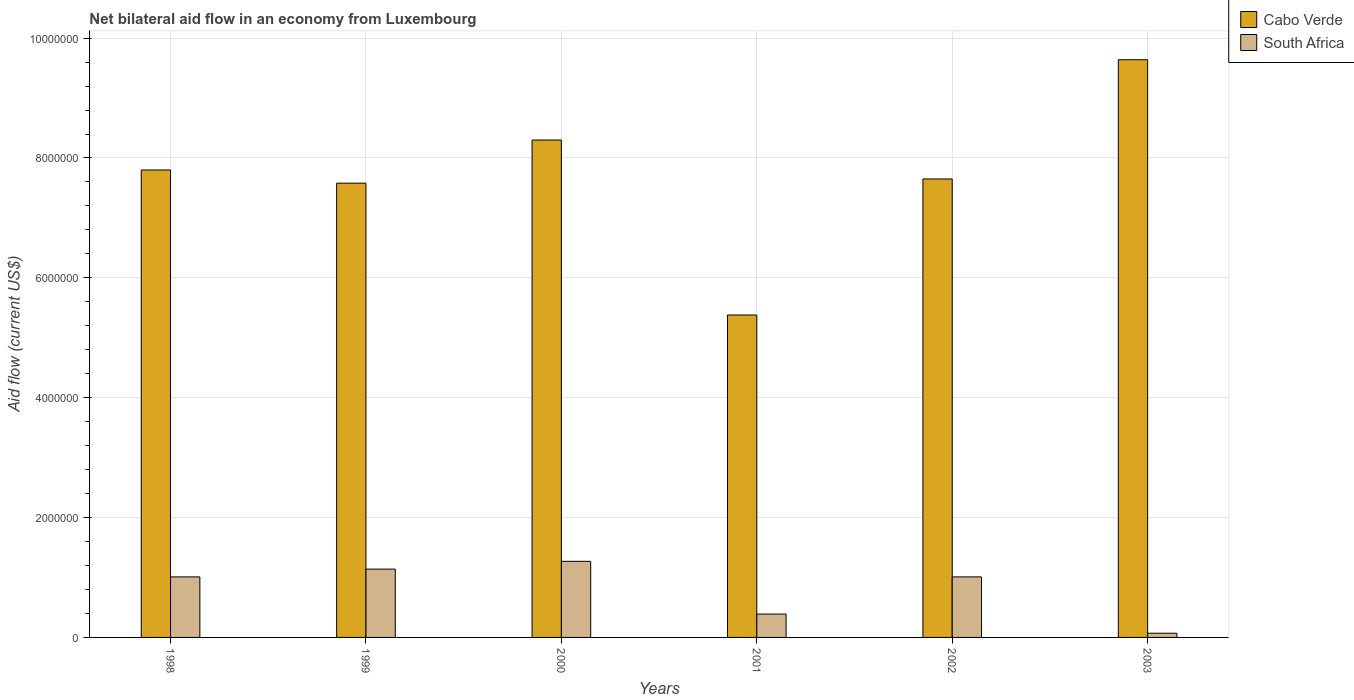How many different coloured bars are there?
Ensure brevity in your answer.  2. Are the number of bars per tick equal to the number of legend labels?
Offer a terse response. Yes. Are the number of bars on each tick of the X-axis equal?
Keep it short and to the point. Yes. How many bars are there on the 5th tick from the right?
Your response must be concise. 2. In how many cases, is the number of bars for a given year not equal to the number of legend labels?
Provide a succinct answer. 0. What is the net bilateral aid flow in Cabo Verde in 1999?
Provide a succinct answer. 7.58e+06. Across all years, what is the maximum net bilateral aid flow in Cabo Verde?
Ensure brevity in your answer.  9.64e+06. Across all years, what is the minimum net bilateral aid flow in South Africa?
Keep it short and to the point. 7.00e+04. In which year was the net bilateral aid flow in South Africa maximum?
Offer a terse response. 2000. In which year was the net bilateral aid flow in Cabo Verde minimum?
Give a very brief answer. 2001. What is the total net bilateral aid flow in Cabo Verde in the graph?
Make the answer very short. 4.64e+07. What is the difference between the net bilateral aid flow in South Africa in 2000 and that in 2001?
Your response must be concise. 8.80e+05. What is the difference between the net bilateral aid flow in Cabo Verde in 2000 and the net bilateral aid flow in South Africa in 1998?
Make the answer very short. 7.29e+06. What is the average net bilateral aid flow in Cabo Verde per year?
Give a very brief answer. 7.72e+06. In the year 1999, what is the difference between the net bilateral aid flow in South Africa and net bilateral aid flow in Cabo Verde?
Offer a terse response. -6.44e+06. In how many years, is the net bilateral aid flow in Cabo Verde greater than 7200000 US$?
Offer a terse response. 5. What is the ratio of the net bilateral aid flow in Cabo Verde in 2001 to that in 2003?
Ensure brevity in your answer.  0.56. Is the difference between the net bilateral aid flow in South Africa in 1998 and 2000 greater than the difference between the net bilateral aid flow in Cabo Verde in 1998 and 2000?
Your response must be concise. Yes. What is the difference between the highest and the second highest net bilateral aid flow in Cabo Verde?
Give a very brief answer. 1.34e+06. What is the difference between the highest and the lowest net bilateral aid flow in South Africa?
Keep it short and to the point. 1.20e+06. In how many years, is the net bilateral aid flow in South Africa greater than the average net bilateral aid flow in South Africa taken over all years?
Provide a short and direct response. 4. Is the sum of the net bilateral aid flow in Cabo Verde in 1998 and 1999 greater than the maximum net bilateral aid flow in South Africa across all years?
Offer a very short reply. Yes. What does the 1st bar from the left in 1999 represents?
Provide a short and direct response. Cabo Verde. What does the 2nd bar from the right in 1998 represents?
Your response must be concise. Cabo Verde. How many bars are there?
Your response must be concise. 12. Are all the bars in the graph horizontal?
Provide a succinct answer. No. How many years are there in the graph?
Give a very brief answer. 6. What is the difference between two consecutive major ticks on the Y-axis?
Keep it short and to the point. 2.00e+06. Does the graph contain any zero values?
Offer a very short reply. No. Does the graph contain grids?
Offer a terse response. Yes. Where does the legend appear in the graph?
Your answer should be very brief. Top right. How many legend labels are there?
Give a very brief answer. 2. How are the legend labels stacked?
Provide a short and direct response. Vertical. What is the title of the graph?
Offer a very short reply. Net bilateral aid flow in an economy from Luxembourg. What is the Aid flow (current US$) of Cabo Verde in 1998?
Your answer should be compact. 7.80e+06. What is the Aid flow (current US$) of South Africa in 1998?
Your answer should be very brief. 1.01e+06. What is the Aid flow (current US$) in Cabo Verde in 1999?
Your answer should be compact. 7.58e+06. What is the Aid flow (current US$) in South Africa in 1999?
Ensure brevity in your answer.  1.14e+06. What is the Aid flow (current US$) in Cabo Verde in 2000?
Keep it short and to the point. 8.30e+06. What is the Aid flow (current US$) of South Africa in 2000?
Make the answer very short. 1.27e+06. What is the Aid flow (current US$) of Cabo Verde in 2001?
Give a very brief answer. 5.38e+06. What is the Aid flow (current US$) in South Africa in 2001?
Ensure brevity in your answer.  3.90e+05. What is the Aid flow (current US$) of Cabo Verde in 2002?
Keep it short and to the point. 7.65e+06. What is the Aid flow (current US$) in South Africa in 2002?
Make the answer very short. 1.01e+06. What is the Aid flow (current US$) of Cabo Verde in 2003?
Make the answer very short. 9.64e+06. Across all years, what is the maximum Aid flow (current US$) in Cabo Verde?
Offer a very short reply. 9.64e+06. Across all years, what is the maximum Aid flow (current US$) of South Africa?
Your answer should be compact. 1.27e+06. Across all years, what is the minimum Aid flow (current US$) of Cabo Verde?
Your answer should be compact. 5.38e+06. Across all years, what is the minimum Aid flow (current US$) in South Africa?
Make the answer very short. 7.00e+04. What is the total Aid flow (current US$) in Cabo Verde in the graph?
Your answer should be very brief. 4.64e+07. What is the total Aid flow (current US$) in South Africa in the graph?
Make the answer very short. 4.89e+06. What is the difference between the Aid flow (current US$) of South Africa in 1998 and that in 1999?
Offer a terse response. -1.30e+05. What is the difference between the Aid flow (current US$) in Cabo Verde in 1998 and that in 2000?
Offer a terse response. -5.00e+05. What is the difference between the Aid flow (current US$) of South Africa in 1998 and that in 2000?
Your response must be concise. -2.60e+05. What is the difference between the Aid flow (current US$) of Cabo Verde in 1998 and that in 2001?
Make the answer very short. 2.42e+06. What is the difference between the Aid flow (current US$) of South Africa in 1998 and that in 2001?
Offer a terse response. 6.20e+05. What is the difference between the Aid flow (current US$) in Cabo Verde in 1998 and that in 2002?
Ensure brevity in your answer.  1.50e+05. What is the difference between the Aid flow (current US$) of Cabo Verde in 1998 and that in 2003?
Your answer should be very brief. -1.84e+06. What is the difference between the Aid flow (current US$) in South Africa in 1998 and that in 2003?
Your answer should be compact. 9.40e+05. What is the difference between the Aid flow (current US$) in Cabo Verde in 1999 and that in 2000?
Provide a succinct answer. -7.20e+05. What is the difference between the Aid flow (current US$) in Cabo Verde in 1999 and that in 2001?
Your answer should be compact. 2.20e+06. What is the difference between the Aid flow (current US$) in South Africa in 1999 and that in 2001?
Your response must be concise. 7.50e+05. What is the difference between the Aid flow (current US$) of Cabo Verde in 1999 and that in 2003?
Offer a very short reply. -2.06e+06. What is the difference between the Aid flow (current US$) of South Africa in 1999 and that in 2003?
Ensure brevity in your answer.  1.07e+06. What is the difference between the Aid flow (current US$) of Cabo Verde in 2000 and that in 2001?
Offer a terse response. 2.92e+06. What is the difference between the Aid flow (current US$) in South Africa in 2000 and that in 2001?
Your answer should be very brief. 8.80e+05. What is the difference between the Aid flow (current US$) in Cabo Verde in 2000 and that in 2002?
Provide a succinct answer. 6.50e+05. What is the difference between the Aid flow (current US$) in Cabo Verde in 2000 and that in 2003?
Your answer should be compact. -1.34e+06. What is the difference between the Aid flow (current US$) of South Africa in 2000 and that in 2003?
Make the answer very short. 1.20e+06. What is the difference between the Aid flow (current US$) of Cabo Verde in 2001 and that in 2002?
Provide a short and direct response. -2.27e+06. What is the difference between the Aid flow (current US$) in South Africa in 2001 and that in 2002?
Your answer should be compact. -6.20e+05. What is the difference between the Aid flow (current US$) of Cabo Verde in 2001 and that in 2003?
Your answer should be compact. -4.26e+06. What is the difference between the Aid flow (current US$) of Cabo Verde in 2002 and that in 2003?
Ensure brevity in your answer.  -1.99e+06. What is the difference between the Aid flow (current US$) in South Africa in 2002 and that in 2003?
Your response must be concise. 9.40e+05. What is the difference between the Aid flow (current US$) of Cabo Verde in 1998 and the Aid flow (current US$) of South Africa in 1999?
Provide a short and direct response. 6.66e+06. What is the difference between the Aid flow (current US$) in Cabo Verde in 1998 and the Aid flow (current US$) in South Africa in 2000?
Ensure brevity in your answer.  6.53e+06. What is the difference between the Aid flow (current US$) in Cabo Verde in 1998 and the Aid flow (current US$) in South Africa in 2001?
Make the answer very short. 7.41e+06. What is the difference between the Aid flow (current US$) in Cabo Verde in 1998 and the Aid flow (current US$) in South Africa in 2002?
Your answer should be very brief. 6.79e+06. What is the difference between the Aid flow (current US$) in Cabo Verde in 1998 and the Aid flow (current US$) in South Africa in 2003?
Keep it short and to the point. 7.73e+06. What is the difference between the Aid flow (current US$) of Cabo Verde in 1999 and the Aid flow (current US$) of South Africa in 2000?
Provide a succinct answer. 6.31e+06. What is the difference between the Aid flow (current US$) in Cabo Verde in 1999 and the Aid flow (current US$) in South Africa in 2001?
Offer a terse response. 7.19e+06. What is the difference between the Aid flow (current US$) of Cabo Verde in 1999 and the Aid flow (current US$) of South Africa in 2002?
Your answer should be compact. 6.57e+06. What is the difference between the Aid flow (current US$) of Cabo Verde in 1999 and the Aid flow (current US$) of South Africa in 2003?
Your answer should be compact. 7.51e+06. What is the difference between the Aid flow (current US$) in Cabo Verde in 2000 and the Aid flow (current US$) in South Africa in 2001?
Ensure brevity in your answer.  7.91e+06. What is the difference between the Aid flow (current US$) in Cabo Verde in 2000 and the Aid flow (current US$) in South Africa in 2002?
Give a very brief answer. 7.29e+06. What is the difference between the Aid flow (current US$) in Cabo Verde in 2000 and the Aid flow (current US$) in South Africa in 2003?
Provide a short and direct response. 8.23e+06. What is the difference between the Aid flow (current US$) of Cabo Verde in 2001 and the Aid flow (current US$) of South Africa in 2002?
Make the answer very short. 4.37e+06. What is the difference between the Aid flow (current US$) in Cabo Verde in 2001 and the Aid flow (current US$) in South Africa in 2003?
Your answer should be very brief. 5.31e+06. What is the difference between the Aid flow (current US$) of Cabo Verde in 2002 and the Aid flow (current US$) of South Africa in 2003?
Offer a terse response. 7.58e+06. What is the average Aid flow (current US$) of Cabo Verde per year?
Offer a very short reply. 7.72e+06. What is the average Aid flow (current US$) in South Africa per year?
Provide a succinct answer. 8.15e+05. In the year 1998, what is the difference between the Aid flow (current US$) of Cabo Verde and Aid flow (current US$) of South Africa?
Give a very brief answer. 6.79e+06. In the year 1999, what is the difference between the Aid flow (current US$) of Cabo Verde and Aid flow (current US$) of South Africa?
Offer a terse response. 6.44e+06. In the year 2000, what is the difference between the Aid flow (current US$) of Cabo Verde and Aid flow (current US$) of South Africa?
Keep it short and to the point. 7.03e+06. In the year 2001, what is the difference between the Aid flow (current US$) in Cabo Verde and Aid flow (current US$) in South Africa?
Keep it short and to the point. 4.99e+06. In the year 2002, what is the difference between the Aid flow (current US$) in Cabo Verde and Aid flow (current US$) in South Africa?
Keep it short and to the point. 6.64e+06. In the year 2003, what is the difference between the Aid flow (current US$) of Cabo Verde and Aid flow (current US$) of South Africa?
Your answer should be very brief. 9.57e+06. What is the ratio of the Aid flow (current US$) in Cabo Verde in 1998 to that in 1999?
Give a very brief answer. 1.03. What is the ratio of the Aid flow (current US$) of South Africa in 1998 to that in 1999?
Offer a very short reply. 0.89. What is the ratio of the Aid flow (current US$) of Cabo Verde in 1998 to that in 2000?
Provide a succinct answer. 0.94. What is the ratio of the Aid flow (current US$) in South Africa in 1998 to that in 2000?
Provide a short and direct response. 0.8. What is the ratio of the Aid flow (current US$) of Cabo Verde in 1998 to that in 2001?
Offer a very short reply. 1.45. What is the ratio of the Aid flow (current US$) in South Africa in 1998 to that in 2001?
Offer a very short reply. 2.59. What is the ratio of the Aid flow (current US$) of Cabo Verde in 1998 to that in 2002?
Offer a very short reply. 1.02. What is the ratio of the Aid flow (current US$) in Cabo Verde in 1998 to that in 2003?
Provide a short and direct response. 0.81. What is the ratio of the Aid flow (current US$) of South Africa in 1998 to that in 2003?
Your response must be concise. 14.43. What is the ratio of the Aid flow (current US$) in Cabo Verde in 1999 to that in 2000?
Provide a succinct answer. 0.91. What is the ratio of the Aid flow (current US$) in South Africa in 1999 to that in 2000?
Give a very brief answer. 0.9. What is the ratio of the Aid flow (current US$) in Cabo Verde in 1999 to that in 2001?
Offer a very short reply. 1.41. What is the ratio of the Aid flow (current US$) in South Africa in 1999 to that in 2001?
Your response must be concise. 2.92. What is the ratio of the Aid flow (current US$) of Cabo Verde in 1999 to that in 2002?
Give a very brief answer. 0.99. What is the ratio of the Aid flow (current US$) in South Africa in 1999 to that in 2002?
Your answer should be very brief. 1.13. What is the ratio of the Aid flow (current US$) in Cabo Verde in 1999 to that in 2003?
Your answer should be very brief. 0.79. What is the ratio of the Aid flow (current US$) of South Africa in 1999 to that in 2003?
Provide a short and direct response. 16.29. What is the ratio of the Aid flow (current US$) of Cabo Verde in 2000 to that in 2001?
Offer a terse response. 1.54. What is the ratio of the Aid flow (current US$) of South Africa in 2000 to that in 2001?
Offer a very short reply. 3.26. What is the ratio of the Aid flow (current US$) in Cabo Verde in 2000 to that in 2002?
Your answer should be compact. 1.08. What is the ratio of the Aid flow (current US$) of South Africa in 2000 to that in 2002?
Your response must be concise. 1.26. What is the ratio of the Aid flow (current US$) of Cabo Verde in 2000 to that in 2003?
Keep it short and to the point. 0.86. What is the ratio of the Aid flow (current US$) of South Africa in 2000 to that in 2003?
Provide a succinct answer. 18.14. What is the ratio of the Aid flow (current US$) in Cabo Verde in 2001 to that in 2002?
Offer a terse response. 0.7. What is the ratio of the Aid flow (current US$) of South Africa in 2001 to that in 2002?
Keep it short and to the point. 0.39. What is the ratio of the Aid flow (current US$) in Cabo Verde in 2001 to that in 2003?
Your answer should be very brief. 0.56. What is the ratio of the Aid flow (current US$) in South Africa in 2001 to that in 2003?
Your answer should be compact. 5.57. What is the ratio of the Aid flow (current US$) of Cabo Verde in 2002 to that in 2003?
Your answer should be compact. 0.79. What is the ratio of the Aid flow (current US$) in South Africa in 2002 to that in 2003?
Offer a very short reply. 14.43. What is the difference between the highest and the second highest Aid flow (current US$) in Cabo Verde?
Your answer should be very brief. 1.34e+06. What is the difference between the highest and the lowest Aid flow (current US$) in Cabo Verde?
Provide a succinct answer. 4.26e+06. What is the difference between the highest and the lowest Aid flow (current US$) of South Africa?
Your response must be concise. 1.20e+06. 